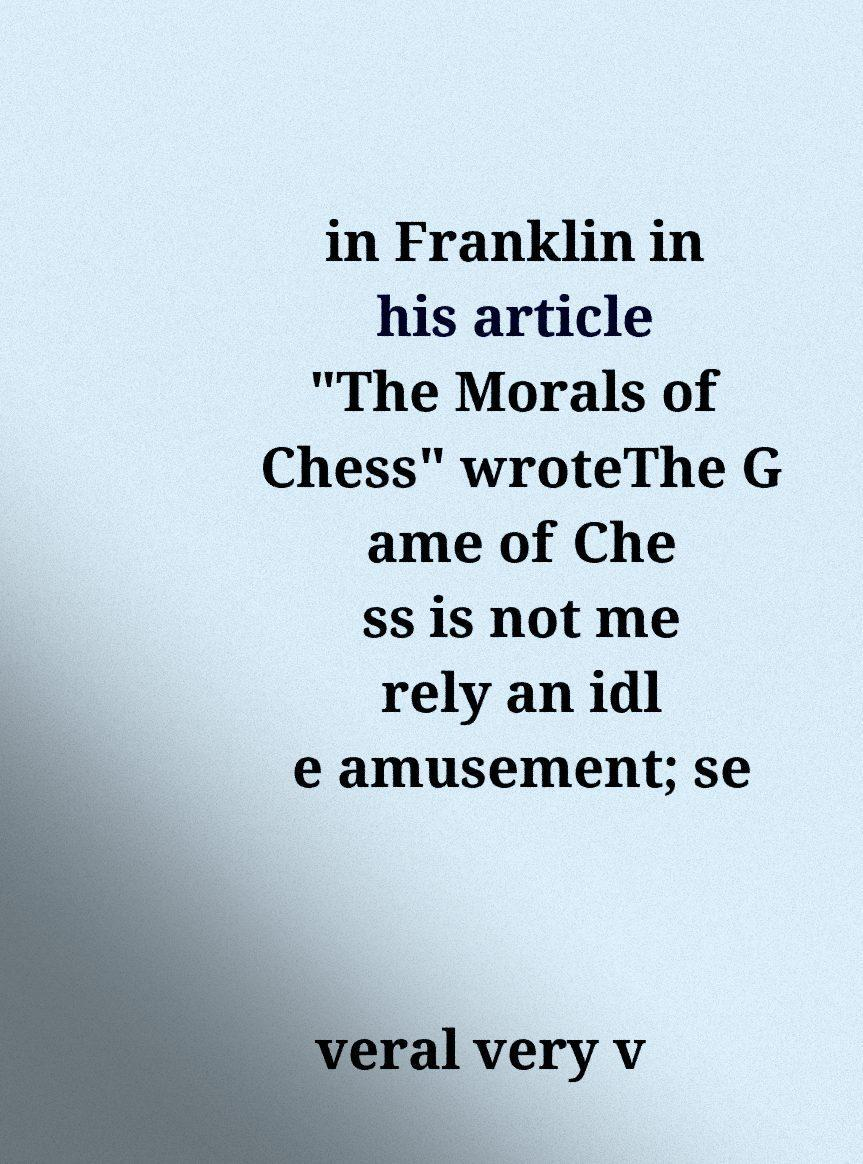For documentation purposes, I need the text within this image transcribed. Could you provide that? in Franklin in his article "The Morals of Chess" wroteThe G ame of Che ss is not me rely an idl e amusement; se veral very v 